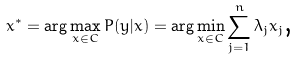Convert formula to latex. <formula><loc_0><loc_0><loc_500><loc_500>x ^ { * } = \arg \max _ { x \in C } P ( y | x ) = \arg \min _ { x \in C } \sum _ { j = 1 } ^ { n } \lambda _ { j } x _ { j } \text {,}</formula> 